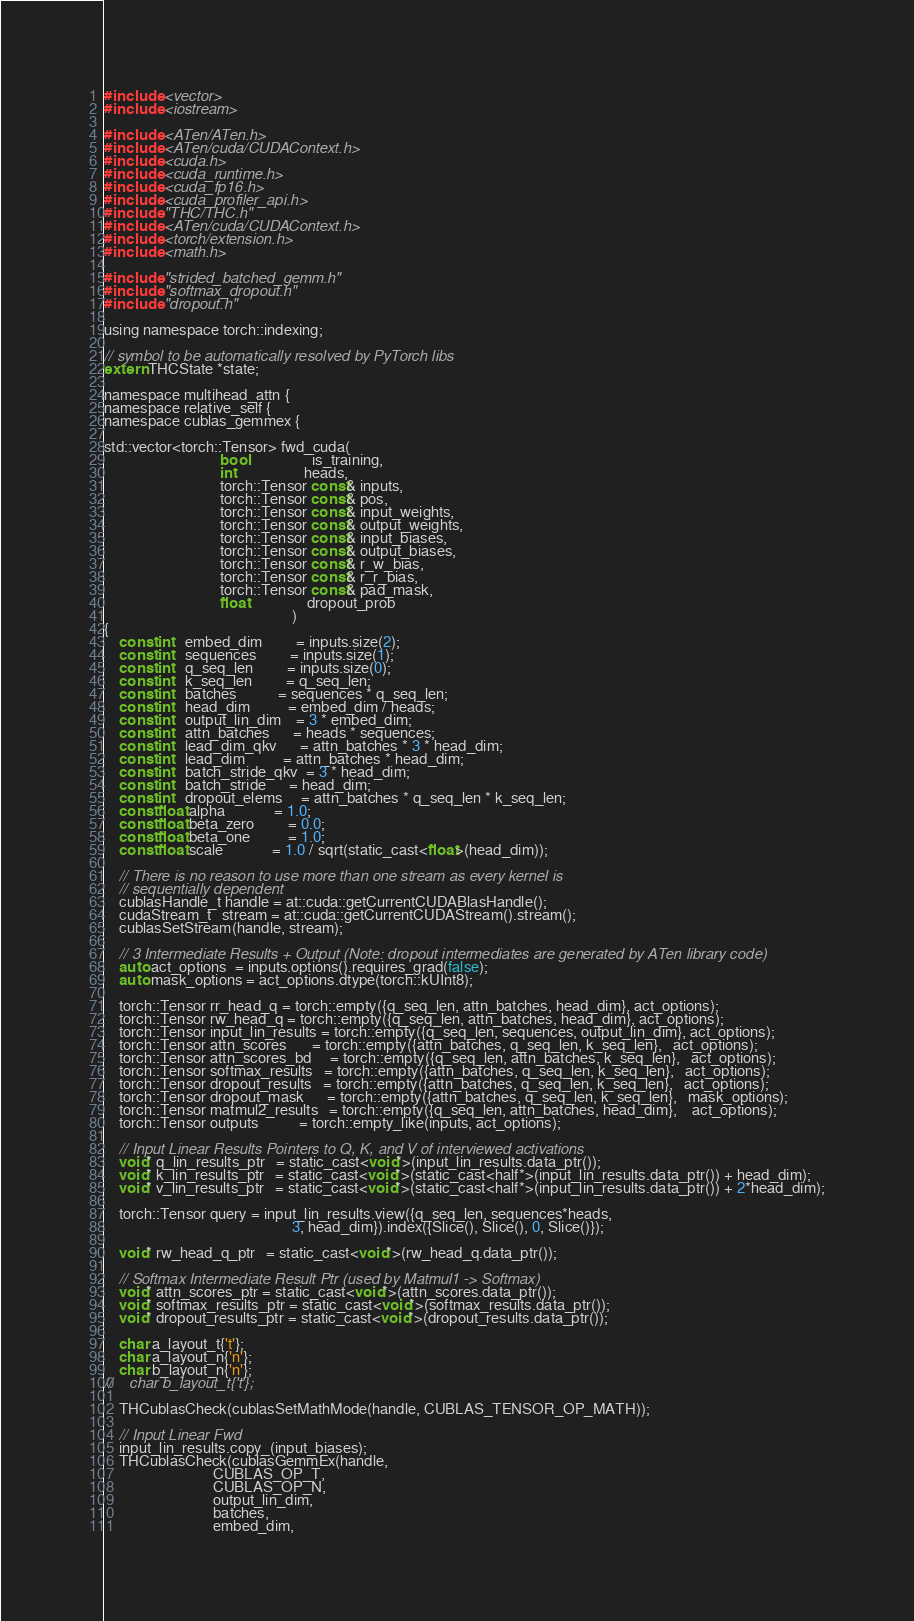Convert code to text. <code><loc_0><loc_0><loc_500><loc_500><_Cuda_>#include <vector>
#include <iostream>

#include <ATen/ATen.h>
#include <ATen/cuda/CUDAContext.h>
#include <cuda.h>
#include <cuda_runtime.h>
#include <cuda_fp16.h>
#include <cuda_profiler_api.h>
#include "THC/THC.h"
#include <ATen/cuda/CUDAContext.h>
#include <torch/extension.h>
#include <math.h>

#include "strided_batched_gemm.h"
#include "softmax_dropout.h"
#include "dropout.h"

using namespace torch::indexing;

// symbol to be automatically resolved by PyTorch libs
extern THCState *state;

namespace multihead_attn {
namespace relative_self {
namespace cublas_gemmex {

std::vector<torch::Tensor> fwd_cuda(
                               bool                 is_training,
                               int                  heads,
                               torch::Tensor const& inputs,
                               torch::Tensor const& pos,
                               torch::Tensor const& input_weights,
                               torch::Tensor const& output_weights,
                               torch::Tensor const& input_biases,
                               torch::Tensor const& output_biases,
                               torch::Tensor const& r_w_bias,
                               torch::Tensor const& r_r_bias,
                               torch::Tensor const& pad_mask,
                               float                dropout_prob
                                                  )
{
    const int   embed_dim         = inputs.size(2);
    const int   sequences         = inputs.size(1);
    const int   q_seq_len         = inputs.size(0);
    const int   k_seq_len         = q_seq_len;
    const int   batches           = sequences * q_seq_len;
    const int   head_dim          = embed_dim / heads;
    const int   output_lin_dim    = 3 * embed_dim;
    const int   attn_batches      = heads * sequences;
    const int   lead_dim_qkv      = attn_batches * 3 * head_dim;
    const int   lead_dim          = attn_batches * head_dim;
    const int   batch_stride_qkv  = 3 * head_dim;
    const int   batch_stride      = head_dim;
    const int   dropout_elems     = attn_batches * q_seq_len * k_seq_len;
    const float alpha             = 1.0;
    const float beta_zero         = 0.0;
    const float beta_one          = 1.0;
    const float scale             = 1.0 / sqrt(static_cast<float>(head_dim));

    // There is no reason to use more than one stream as every kernel is
    // sequentially dependent
    cublasHandle_t handle = at::cuda::getCurrentCUDABlasHandle();
    cudaStream_t   stream = at::cuda::getCurrentCUDAStream().stream();
    cublasSetStream(handle, stream);

    // 3 Intermediate Results + Output (Note: dropout intermediates are generated by ATen library code)
    auto act_options  = inputs.options().requires_grad(false);
    auto mask_options = act_options.dtype(torch::kUInt8);

    torch::Tensor rr_head_q = torch::empty({q_seq_len, attn_batches, head_dim}, act_options);
    torch::Tensor rw_head_q = torch::empty({q_seq_len, attn_batches, head_dim}, act_options);
    torch::Tensor input_lin_results = torch::empty({q_seq_len, sequences, output_lin_dim}, act_options);
    torch::Tensor attn_scores       = torch::empty({attn_batches, q_seq_len, k_seq_len},   act_options);
    torch::Tensor attn_scores_bd     = torch::empty({q_seq_len, attn_batches, k_seq_len},   act_options);
    torch::Tensor softmax_results   = torch::empty({attn_batches, q_seq_len, k_seq_len},   act_options);
    torch::Tensor dropout_results   = torch::empty({attn_batches, q_seq_len, k_seq_len},   act_options);
    torch::Tensor dropout_mask      = torch::empty({attn_batches, q_seq_len, k_seq_len},   mask_options);
    torch::Tensor matmul2_results   = torch::empty({q_seq_len, attn_batches, head_dim},    act_options);
    torch::Tensor outputs           = torch::empty_like(inputs, act_options);

    // Input Linear Results Pointers to Q, K, and V of interviewed activations
    void* q_lin_results_ptr   = static_cast<void*>(input_lin_results.data_ptr());
    void* k_lin_results_ptr   = static_cast<void*>(static_cast<half*>(input_lin_results.data_ptr()) + head_dim);
    void* v_lin_results_ptr   = static_cast<void*>(static_cast<half*>(input_lin_results.data_ptr()) + 2*head_dim);

    torch::Tensor query = input_lin_results.view({q_seq_len, sequences*heads,
                                                  3, head_dim}).index({Slice(), Slice(), 0, Slice()});

    void* rw_head_q_ptr   = static_cast<void*>(rw_head_q.data_ptr());

    // Softmax Intermediate Result Ptr (used by Matmul1 -> Softmax)
    void* attn_scores_ptr = static_cast<void*>(attn_scores.data_ptr());
    void* softmax_results_ptr = static_cast<void*>(softmax_results.data_ptr());
    void* dropout_results_ptr = static_cast<void*>(dropout_results.data_ptr());

    char a_layout_t{'t'};
    char a_layout_n{'n'};
    char b_layout_n{'n'};
//    char b_layout_t{'t'};

    THCublasCheck(cublasSetMathMode(handle, CUBLAS_TENSOR_OP_MATH));

    // Input Linear Fwd
    input_lin_results.copy_(input_biases);
    THCublasCheck(cublasGemmEx(handle,
                             CUBLAS_OP_T,
                             CUBLAS_OP_N,
                             output_lin_dim,
                             batches,
                             embed_dim,</code> 